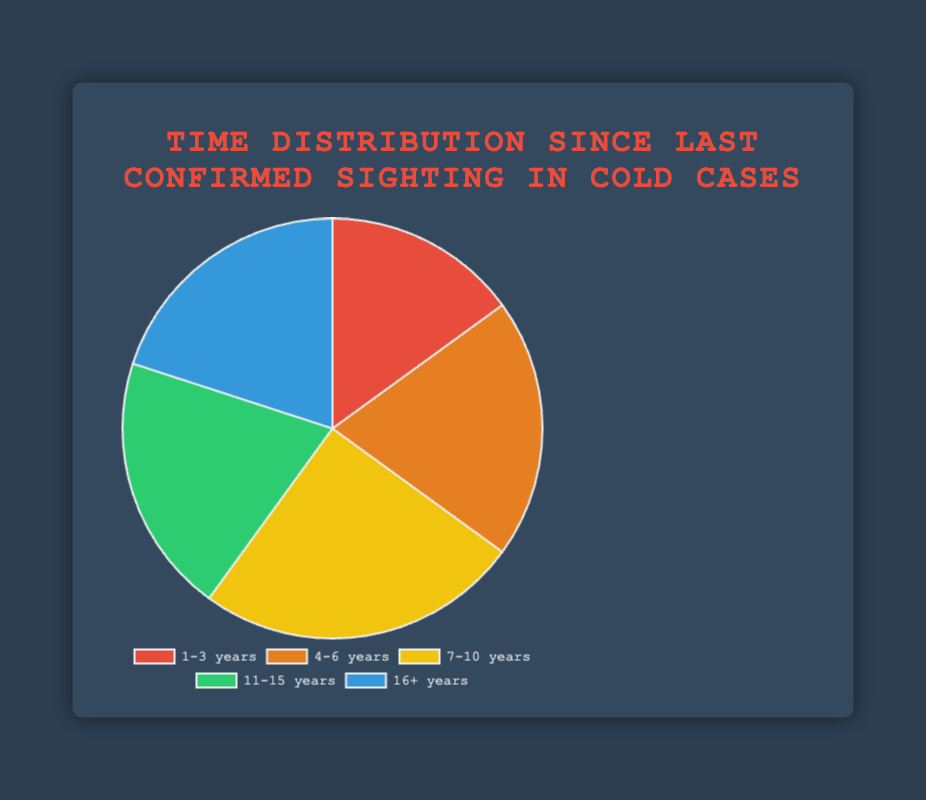What is the most common time range since the last confirmed sighting in cold cases? The "7-10 years" time range has the highest percentage (25%).
Answer: 7-10 years Which time ranges have the same percentage of cases since the last confirmed sighting? The "4-6 years", "11-15 years", and "16+ years" time ranges each have 20%.
Answer: 4-6 years, 11-15 years, 16+ years What is the combined percentage of cases that are in the 7-10 years and 1-3 years ranges? The percentage for "7-10 years" is 25%, and for "1-3 years" is 15%. Adding these gives 40%.
Answer: 40% Which color represents the time range with the highest percentage? The "7-10 years" time range, which has the highest percentage, is represented by yellow.
Answer: Yellow How does the percentage of "11-15 years" compare to "1-3 years"? The percentages are 20% for "11-15 years" and 15% for "1-3 years". 20% is greater than 15%.
Answer: "11-15 years" is greater What is the total percentage of cases for time ranges that are 4+ years since the last confirmed sighting? The percentages for "4-6 years", "7-10 years", "11-15 years", and "16+ years" are 20%, 25%, 20%, and 20% respectively. Adding them gives 85%.
Answer: 85% Which time range has more cases, the 4-6 years or the 1-3 years range? The "4-6 years" time range has 20% compared to "1-3 years" at 15%. 20% is more than 15%.
Answer: 4-6 years What fraction of time ranges account for 20% of the total cases? There are three time ranges ("4-6 years", "11-15 years", and "16+ years") accounting for 20% each out of five total time ranges. This is 3/5.
Answer: 3/5 What is the median time range in terms of percentage since the last confirmed sighting? The percentages are 15%, 20%, 25%, 20%, and 20%. The median is the middle value, which is 20%.
Answer: 20% 